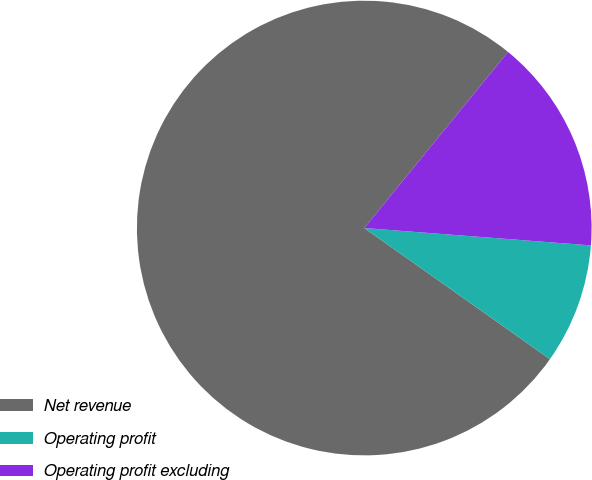Convert chart. <chart><loc_0><loc_0><loc_500><loc_500><pie_chart><fcel>Net revenue<fcel>Operating profit<fcel>Operating profit excluding<nl><fcel>76.11%<fcel>8.57%<fcel>15.32%<nl></chart> 